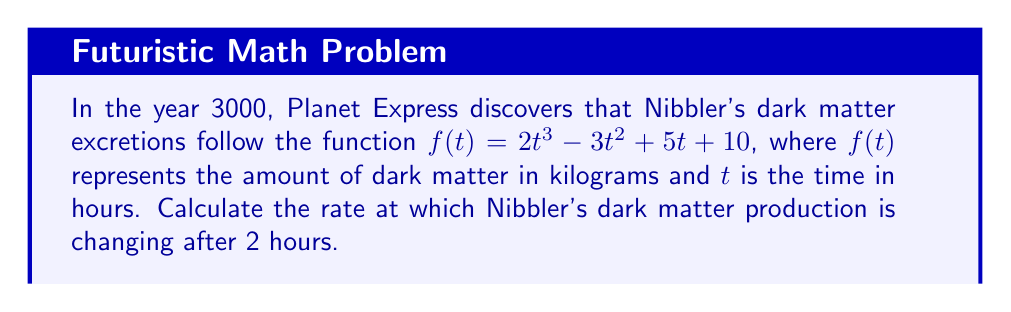Can you solve this math problem? To solve this problem, we need to follow these steps:

1) The rate of change of Nibbler's dark matter production is given by the derivative of the function $f(t)$.

2) Let's find the derivative of $f(t) = 2t^3 - 3t^2 + 5t + 10$:
   
   $f'(t) = 6t^2 - 6t + 5$

3) This derivative function $f'(t)$ gives us the instantaneous rate of change at any time $t$.

4) We're asked about the rate of change after 2 hours, so we need to evaluate $f'(2)$:

   $f'(2) = 6(2)^2 - 6(2) + 5$
   
   $f'(2) = 6(4) - 12 + 5$
   
   $f'(2) = 24 - 12 + 5 = 17$

5) Therefore, after 2 hours, the rate of change of Nibbler's dark matter production is 17 kg/hour.
Answer: 17 kg/hour 